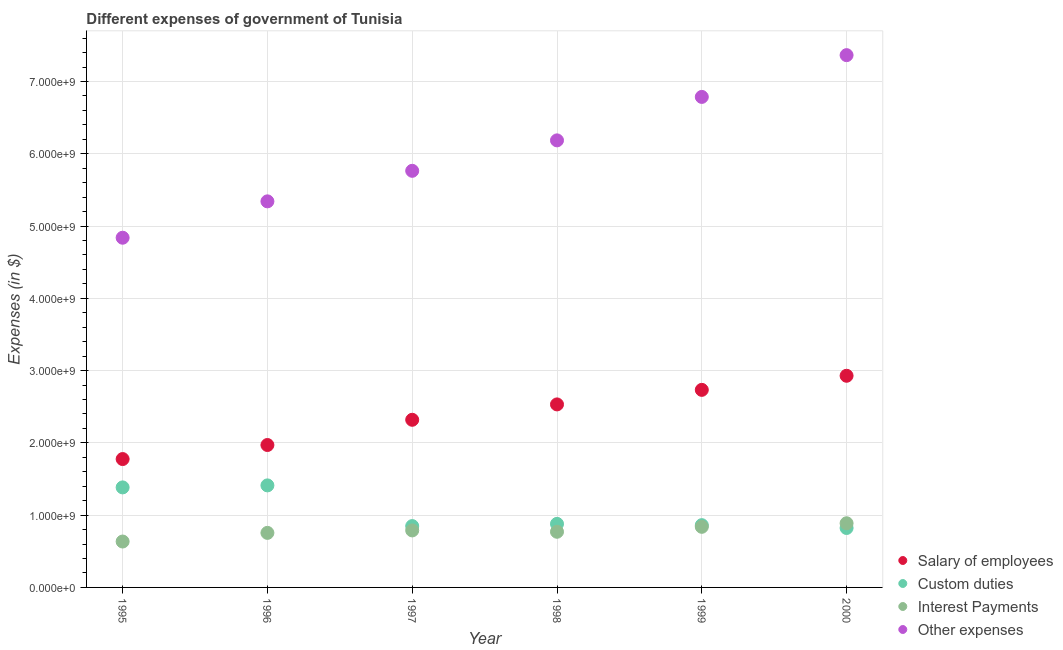How many different coloured dotlines are there?
Your answer should be very brief. 4. Is the number of dotlines equal to the number of legend labels?
Your response must be concise. Yes. What is the amount spent on custom duties in 1997?
Keep it short and to the point. 8.49e+08. Across all years, what is the maximum amount spent on custom duties?
Make the answer very short. 1.41e+09. Across all years, what is the minimum amount spent on custom duties?
Make the answer very short. 8.22e+08. In which year was the amount spent on salary of employees maximum?
Ensure brevity in your answer.  2000. In which year was the amount spent on interest payments minimum?
Provide a succinct answer. 1995. What is the total amount spent on custom duties in the graph?
Give a very brief answer. 6.21e+09. What is the difference between the amount spent on other expenses in 1995 and that in 2000?
Keep it short and to the point. -2.53e+09. What is the difference between the amount spent on interest payments in 1999 and the amount spent on salary of employees in 1996?
Ensure brevity in your answer.  -1.13e+09. What is the average amount spent on interest payments per year?
Ensure brevity in your answer.  7.79e+08. In the year 1995, what is the difference between the amount spent on other expenses and amount spent on interest payments?
Make the answer very short. 4.20e+09. In how many years, is the amount spent on salary of employees greater than 2000000000 $?
Provide a short and direct response. 4. What is the ratio of the amount spent on interest payments in 1995 to that in 1998?
Your response must be concise. 0.82. Is the difference between the amount spent on interest payments in 1996 and 1999 greater than the difference between the amount spent on salary of employees in 1996 and 1999?
Your response must be concise. Yes. What is the difference between the highest and the second highest amount spent on other expenses?
Your response must be concise. 5.78e+08. What is the difference between the highest and the lowest amount spent on other expenses?
Give a very brief answer. 2.53e+09. In how many years, is the amount spent on other expenses greater than the average amount spent on other expenses taken over all years?
Provide a succinct answer. 3. Is the sum of the amount spent on other expenses in 1998 and 2000 greater than the maximum amount spent on salary of employees across all years?
Provide a short and direct response. Yes. Is it the case that in every year, the sum of the amount spent on custom duties and amount spent on interest payments is greater than the sum of amount spent on salary of employees and amount spent on other expenses?
Give a very brief answer. No. Is the amount spent on custom duties strictly greater than the amount spent on other expenses over the years?
Offer a terse response. No. Is the amount spent on salary of employees strictly less than the amount spent on interest payments over the years?
Your answer should be very brief. No. What is the difference between two consecutive major ticks on the Y-axis?
Keep it short and to the point. 1.00e+09. Where does the legend appear in the graph?
Provide a succinct answer. Bottom right. How many legend labels are there?
Give a very brief answer. 4. What is the title of the graph?
Keep it short and to the point. Different expenses of government of Tunisia. What is the label or title of the X-axis?
Ensure brevity in your answer.  Year. What is the label or title of the Y-axis?
Provide a short and direct response. Expenses (in $). What is the Expenses (in $) in Salary of employees in 1995?
Provide a succinct answer. 1.78e+09. What is the Expenses (in $) of Custom duties in 1995?
Your answer should be compact. 1.38e+09. What is the Expenses (in $) of Interest Payments in 1995?
Ensure brevity in your answer.  6.35e+08. What is the Expenses (in $) of Other expenses in 1995?
Ensure brevity in your answer.  4.84e+09. What is the Expenses (in $) in Salary of employees in 1996?
Make the answer very short. 1.97e+09. What is the Expenses (in $) of Custom duties in 1996?
Give a very brief answer. 1.41e+09. What is the Expenses (in $) in Interest Payments in 1996?
Provide a short and direct response. 7.55e+08. What is the Expenses (in $) in Other expenses in 1996?
Provide a succinct answer. 5.34e+09. What is the Expenses (in $) of Salary of employees in 1997?
Provide a succinct answer. 2.32e+09. What is the Expenses (in $) of Custom duties in 1997?
Give a very brief answer. 8.49e+08. What is the Expenses (in $) of Interest Payments in 1997?
Provide a succinct answer. 7.89e+08. What is the Expenses (in $) in Other expenses in 1997?
Your answer should be compact. 5.76e+09. What is the Expenses (in $) of Salary of employees in 1998?
Provide a succinct answer. 2.53e+09. What is the Expenses (in $) of Custom duties in 1998?
Your answer should be compact. 8.79e+08. What is the Expenses (in $) in Interest Payments in 1998?
Your answer should be compact. 7.70e+08. What is the Expenses (in $) in Other expenses in 1998?
Provide a succinct answer. 6.19e+09. What is the Expenses (in $) in Salary of employees in 1999?
Ensure brevity in your answer.  2.73e+09. What is the Expenses (in $) in Custom duties in 1999?
Offer a very short reply. 8.62e+08. What is the Expenses (in $) in Interest Payments in 1999?
Provide a short and direct response. 8.38e+08. What is the Expenses (in $) in Other expenses in 1999?
Keep it short and to the point. 6.79e+09. What is the Expenses (in $) of Salary of employees in 2000?
Your response must be concise. 2.93e+09. What is the Expenses (in $) of Custom duties in 2000?
Offer a very short reply. 8.22e+08. What is the Expenses (in $) in Interest Payments in 2000?
Give a very brief answer. 8.88e+08. What is the Expenses (in $) of Other expenses in 2000?
Keep it short and to the point. 7.36e+09. Across all years, what is the maximum Expenses (in $) in Salary of employees?
Ensure brevity in your answer.  2.93e+09. Across all years, what is the maximum Expenses (in $) of Custom duties?
Your answer should be compact. 1.41e+09. Across all years, what is the maximum Expenses (in $) of Interest Payments?
Your answer should be very brief. 8.88e+08. Across all years, what is the maximum Expenses (in $) in Other expenses?
Give a very brief answer. 7.36e+09. Across all years, what is the minimum Expenses (in $) in Salary of employees?
Keep it short and to the point. 1.78e+09. Across all years, what is the minimum Expenses (in $) in Custom duties?
Ensure brevity in your answer.  8.22e+08. Across all years, what is the minimum Expenses (in $) in Interest Payments?
Your response must be concise. 6.35e+08. Across all years, what is the minimum Expenses (in $) in Other expenses?
Make the answer very short. 4.84e+09. What is the total Expenses (in $) in Salary of employees in the graph?
Your answer should be very brief. 1.43e+1. What is the total Expenses (in $) of Custom duties in the graph?
Give a very brief answer. 6.21e+09. What is the total Expenses (in $) of Interest Payments in the graph?
Provide a short and direct response. 4.67e+09. What is the total Expenses (in $) of Other expenses in the graph?
Give a very brief answer. 3.63e+1. What is the difference between the Expenses (in $) of Salary of employees in 1995 and that in 1996?
Provide a short and direct response. -1.94e+08. What is the difference between the Expenses (in $) in Custom duties in 1995 and that in 1996?
Offer a very short reply. -2.77e+07. What is the difference between the Expenses (in $) of Interest Payments in 1995 and that in 1996?
Ensure brevity in your answer.  -1.20e+08. What is the difference between the Expenses (in $) of Other expenses in 1995 and that in 1996?
Offer a terse response. -5.03e+08. What is the difference between the Expenses (in $) in Salary of employees in 1995 and that in 1997?
Your response must be concise. -5.43e+08. What is the difference between the Expenses (in $) in Custom duties in 1995 and that in 1997?
Keep it short and to the point. 5.35e+08. What is the difference between the Expenses (in $) of Interest Payments in 1995 and that in 1997?
Your answer should be very brief. -1.54e+08. What is the difference between the Expenses (in $) of Other expenses in 1995 and that in 1997?
Offer a terse response. -9.26e+08. What is the difference between the Expenses (in $) of Salary of employees in 1995 and that in 1998?
Your response must be concise. -7.56e+08. What is the difference between the Expenses (in $) in Custom duties in 1995 and that in 1998?
Offer a terse response. 5.05e+08. What is the difference between the Expenses (in $) of Interest Payments in 1995 and that in 1998?
Your response must be concise. -1.35e+08. What is the difference between the Expenses (in $) of Other expenses in 1995 and that in 1998?
Keep it short and to the point. -1.35e+09. What is the difference between the Expenses (in $) of Salary of employees in 1995 and that in 1999?
Provide a succinct answer. -9.57e+08. What is the difference between the Expenses (in $) of Custom duties in 1995 and that in 1999?
Your response must be concise. 5.22e+08. What is the difference between the Expenses (in $) in Interest Payments in 1995 and that in 1999?
Give a very brief answer. -2.03e+08. What is the difference between the Expenses (in $) in Other expenses in 1995 and that in 1999?
Offer a very short reply. -1.95e+09. What is the difference between the Expenses (in $) of Salary of employees in 1995 and that in 2000?
Give a very brief answer. -1.15e+09. What is the difference between the Expenses (in $) in Custom duties in 1995 and that in 2000?
Your response must be concise. 5.62e+08. What is the difference between the Expenses (in $) in Interest Payments in 1995 and that in 2000?
Provide a succinct answer. -2.53e+08. What is the difference between the Expenses (in $) in Other expenses in 1995 and that in 2000?
Your response must be concise. -2.53e+09. What is the difference between the Expenses (in $) of Salary of employees in 1996 and that in 1997?
Offer a very short reply. -3.49e+08. What is the difference between the Expenses (in $) in Custom duties in 1996 and that in 1997?
Provide a short and direct response. 5.63e+08. What is the difference between the Expenses (in $) of Interest Payments in 1996 and that in 1997?
Make the answer very short. -3.40e+07. What is the difference between the Expenses (in $) of Other expenses in 1996 and that in 1997?
Ensure brevity in your answer.  -4.22e+08. What is the difference between the Expenses (in $) in Salary of employees in 1996 and that in 1998?
Your answer should be very brief. -5.62e+08. What is the difference between the Expenses (in $) of Custom duties in 1996 and that in 1998?
Your answer should be very brief. 5.32e+08. What is the difference between the Expenses (in $) in Interest Payments in 1996 and that in 1998?
Provide a succinct answer. -1.53e+07. What is the difference between the Expenses (in $) of Other expenses in 1996 and that in 1998?
Your response must be concise. -8.44e+08. What is the difference between the Expenses (in $) of Salary of employees in 1996 and that in 1999?
Make the answer very short. -7.63e+08. What is the difference between the Expenses (in $) of Custom duties in 1996 and that in 1999?
Your answer should be compact. 5.50e+08. What is the difference between the Expenses (in $) in Interest Payments in 1996 and that in 1999?
Keep it short and to the point. -8.38e+07. What is the difference between the Expenses (in $) of Other expenses in 1996 and that in 1999?
Provide a short and direct response. -1.44e+09. What is the difference between the Expenses (in $) of Salary of employees in 1996 and that in 2000?
Your answer should be very brief. -9.58e+08. What is the difference between the Expenses (in $) in Custom duties in 1996 and that in 2000?
Offer a terse response. 5.89e+08. What is the difference between the Expenses (in $) of Interest Payments in 1996 and that in 2000?
Offer a very short reply. -1.33e+08. What is the difference between the Expenses (in $) in Other expenses in 1996 and that in 2000?
Offer a terse response. -2.02e+09. What is the difference between the Expenses (in $) of Salary of employees in 1997 and that in 1998?
Ensure brevity in your answer.  -2.13e+08. What is the difference between the Expenses (in $) of Custom duties in 1997 and that in 1998?
Your answer should be compact. -3.08e+07. What is the difference between the Expenses (in $) of Interest Payments in 1997 and that in 1998?
Offer a terse response. 1.87e+07. What is the difference between the Expenses (in $) of Other expenses in 1997 and that in 1998?
Keep it short and to the point. -4.21e+08. What is the difference between the Expenses (in $) in Salary of employees in 1997 and that in 1999?
Give a very brief answer. -4.14e+08. What is the difference between the Expenses (in $) of Custom duties in 1997 and that in 1999?
Ensure brevity in your answer.  -1.29e+07. What is the difference between the Expenses (in $) of Interest Payments in 1997 and that in 1999?
Your answer should be very brief. -4.98e+07. What is the difference between the Expenses (in $) in Other expenses in 1997 and that in 1999?
Your response must be concise. -1.02e+09. What is the difference between the Expenses (in $) of Salary of employees in 1997 and that in 2000?
Provide a short and direct response. -6.09e+08. What is the difference between the Expenses (in $) of Custom duties in 1997 and that in 2000?
Provide a succinct answer. 2.62e+07. What is the difference between the Expenses (in $) of Interest Payments in 1997 and that in 2000?
Your answer should be compact. -9.91e+07. What is the difference between the Expenses (in $) of Other expenses in 1997 and that in 2000?
Offer a very short reply. -1.60e+09. What is the difference between the Expenses (in $) of Salary of employees in 1998 and that in 1999?
Give a very brief answer. -2.01e+08. What is the difference between the Expenses (in $) of Custom duties in 1998 and that in 1999?
Your answer should be compact. 1.79e+07. What is the difference between the Expenses (in $) of Interest Payments in 1998 and that in 1999?
Offer a very short reply. -6.85e+07. What is the difference between the Expenses (in $) of Other expenses in 1998 and that in 1999?
Provide a short and direct response. -6.01e+08. What is the difference between the Expenses (in $) in Salary of employees in 1998 and that in 2000?
Provide a succinct answer. -3.96e+08. What is the difference between the Expenses (in $) of Custom duties in 1998 and that in 2000?
Give a very brief answer. 5.70e+07. What is the difference between the Expenses (in $) in Interest Payments in 1998 and that in 2000?
Give a very brief answer. -1.18e+08. What is the difference between the Expenses (in $) of Other expenses in 1998 and that in 2000?
Offer a terse response. -1.18e+09. What is the difference between the Expenses (in $) in Salary of employees in 1999 and that in 2000?
Offer a terse response. -1.95e+08. What is the difference between the Expenses (in $) in Custom duties in 1999 and that in 2000?
Make the answer very short. 3.91e+07. What is the difference between the Expenses (in $) of Interest Payments in 1999 and that in 2000?
Keep it short and to the point. -4.93e+07. What is the difference between the Expenses (in $) in Other expenses in 1999 and that in 2000?
Provide a succinct answer. -5.78e+08. What is the difference between the Expenses (in $) of Salary of employees in 1995 and the Expenses (in $) of Custom duties in 1996?
Provide a succinct answer. 3.64e+08. What is the difference between the Expenses (in $) in Salary of employees in 1995 and the Expenses (in $) in Interest Payments in 1996?
Keep it short and to the point. 1.02e+09. What is the difference between the Expenses (in $) in Salary of employees in 1995 and the Expenses (in $) in Other expenses in 1996?
Offer a terse response. -3.57e+09. What is the difference between the Expenses (in $) in Custom duties in 1995 and the Expenses (in $) in Interest Payments in 1996?
Give a very brief answer. 6.29e+08. What is the difference between the Expenses (in $) of Custom duties in 1995 and the Expenses (in $) of Other expenses in 1996?
Your answer should be compact. -3.96e+09. What is the difference between the Expenses (in $) of Interest Payments in 1995 and the Expenses (in $) of Other expenses in 1996?
Your response must be concise. -4.71e+09. What is the difference between the Expenses (in $) of Salary of employees in 1995 and the Expenses (in $) of Custom duties in 1997?
Your answer should be compact. 9.28e+08. What is the difference between the Expenses (in $) of Salary of employees in 1995 and the Expenses (in $) of Interest Payments in 1997?
Your answer should be very brief. 9.88e+08. What is the difference between the Expenses (in $) of Salary of employees in 1995 and the Expenses (in $) of Other expenses in 1997?
Give a very brief answer. -3.99e+09. What is the difference between the Expenses (in $) of Custom duties in 1995 and the Expenses (in $) of Interest Payments in 1997?
Offer a very short reply. 5.95e+08. What is the difference between the Expenses (in $) in Custom duties in 1995 and the Expenses (in $) in Other expenses in 1997?
Offer a very short reply. -4.38e+09. What is the difference between the Expenses (in $) of Interest Payments in 1995 and the Expenses (in $) of Other expenses in 1997?
Your answer should be compact. -5.13e+09. What is the difference between the Expenses (in $) in Salary of employees in 1995 and the Expenses (in $) in Custom duties in 1998?
Keep it short and to the point. 8.97e+08. What is the difference between the Expenses (in $) in Salary of employees in 1995 and the Expenses (in $) in Interest Payments in 1998?
Your answer should be compact. 1.01e+09. What is the difference between the Expenses (in $) in Salary of employees in 1995 and the Expenses (in $) in Other expenses in 1998?
Offer a very short reply. -4.41e+09. What is the difference between the Expenses (in $) of Custom duties in 1995 and the Expenses (in $) of Interest Payments in 1998?
Ensure brevity in your answer.  6.14e+08. What is the difference between the Expenses (in $) in Custom duties in 1995 and the Expenses (in $) in Other expenses in 1998?
Your response must be concise. -4.80e+09. What is the difference between the Expenses (in $) in Interest Payments in 1995 and the Expenses (in $) in Other expenses in 1998?
Provide a short and direct response. -5.55e+09. What is the difference between the Expenses (in $) of Salary of employees in 1995 and the Expenses (in $) of Custom duties in 1999?
Offer a terse response. 9.15e+08. What is the difference between the Expenses (in $) of Salary of employees in 1995 and the Expenses (in $) of Interest Payments in 1999?
Give a very brief answer. 9.38e+08. What is the difference between the Expenses (in $) of Salary of employees in 1995 and the Expenses (in $) of Other expenses in 1999?
Make the answer very short. -5.01e+09. What is the difference between the Expenses (in $) of Custom duties in 1995 and the Expenses (in $) of Interest Payments in 1999?
Keep it short and to the point. 5.46e+08. What is the difference between the Expenses (in $) of Custom duties in 1995 and the Expenses (in $) of Other expenses in 1999?
Provide a short and direct response. -5.40e+09. What is the difference between the Expenses (in $) of Interest Payments in 1995 and the Expenses (in $) of Other expenses in 1999?
Your response must be concise. -6.15e+09. What is the difference between the Expenses (in $) in Salary of employees in 1995 and the Expenses (in $) in Custom duties in 2000?
Your answer should be very brief. 9.54e+08. What is the difference between the Expenses (in $) of Salary of employees in 1995 and the Expenses (in $) of Interest Payments in 2000?
Give a very brief answer. 8.88e+08. What is the difference between the Expenses (in $) of Salary of employees in 1995 and the Expenses (in $) of Other expenses in 2000?
Your answer should be compact. -5.59e+09. What is the difference between the Expenses (in $) in Custom duties in 1995 and the Expenses (in $) in Interest Payments in 2000?
Make the answer very short. 4.96e+08. What is the difference between the Expenses (in $) of Custom duties in 1995 and the Expenses (in $) of Other expenses in 2000?
Make the answer very short. -5.98e+09. What is the difference between the Expenses (in $) in Interest Payments in 1995 and the Expenses (in $) in Other expenses in 2000?
Your answer should be very brief. -6.73e+09. What is the difference between the Expenses (in $) of Salary of employees in 1996 and the Expenses (in $) of Custom duties in 1997?
Make the answer very short. 1.12e+09. What is the difference between the Expenses (in $) of Salary of employees in 1996 and the Expenses (in $) of Interest Payments in 1997?
Offer a terse response. 1.18e+09. What is the difference between the Expenses (in $) of Salary of employees in 1996 and the Expenses (in $) of Other expenses in 1997?
Make the answer very short. -3.79e+09. What is the difference between the Expenses (in $) of Custom duties in 1996 and the Expenses (in $) of Interest Payments in 1997?
Offer a very short reply. 6.23e+08. What is the difference between the Expenses (in $) in Custom duties in 1996 and the Expenses (in $) in Other expenses in 1997?
Provide a succinct answer. -4.35e+09. What is the difference between the Expenses (in $) in Interest Payments in 1996 and the Expenses (in $) in Other expenses in 1997?
Offer a terse response. -5.01e+09. What is the difference between the Expenses (in $) in Salary of employees in 1996 and the Expenses (in $) in Custom duties in 1998?
Your answer should be very brief. 1.09e+09. What is the difference between the Expenses (in $) in Salary of employees in 1996 and the Expenses (in $) in Interest Payments in 1998?
Your answer should be compact. 1.20e+09. What is the difference between the Expenses (in $) in Salary of employees in 1996 and the Expenses (in $) in Other expenses in 1998?
Your answer should be very brief. -4.21e+09. What is the difference between the Expenses (in $) of Custom duties in 1996 and the Expenses (in $) of Interest Payments in 1998?
Give a very brief answer. 6.42e+08. What is the difference between the Expenses (in $) in Custom duties in 1996 and the Expenses (in $) in Other expenses in 1998?
Provide a succinct answer. -4.77e+09. What is the difference between the Expenses (in $) of Interest Payments in 1996 and the Expenses (in $) of Other expenses in 1998?
Make the answer very short. -5.43e+09. What is the difference between the Expenses (in $) in Salary of employees in 1996 and the Expenses (in $) in Custom duties in 1999?
Provide a succinct answer. 1.11e+09. What is the difference between the Expenses (in $) in Salary of employees in 1996 and the Expenses (in $) in Interest Payments in 1999?
Give a very brief answer. 1.13e+09. What is the difference between the Expenses (in $) of Salary of employees in 1996 and the Expenses (in $) of Other expenses in 1999?
Ensure brevity in your answer.  -4.82e+09. What is the difference between the Expenses (in $) of Custom duties in 1996 and the Expenses (in $) of Interest Payments in 1999?
Your answer should be very brief. 5.73e+08. What is the difference between the Expenses (in $) in Custom duties in 1996 and the Expenses (in $) in Other expenses in 1999?
Provide a short and direct response. -5.38e+09. What is the difference between the Expenses (in $) in Interest Payments in 1996 and the Expenses (in $) in Other expenses in 1999?
Your answer should be very brief. -6.03e+09. What is the difference between the Expenses (in $) of Salary of employees in 1996 and the Expenses (in $) of Custom duties in 2000?
Ensure brevity in your answer.  1.15e+09. What is the difference between the Expenses (in $) of Salary of employees in 1996 and the Expenses (in $) of Interest Payments in 2000?
Provide a succinct answer. 1.08e+09. What is the difference between the Expenses (in $) in Salary of employees in 1996 and the Expenses (in $) in Other expenses in 2000?
Give a very brief answer. -5.39e+09. What is the difference between the Expenses (in $) in Custom duties in 1996 and the Expenses (in $) in Interest Payments in 2000?
Give a very brief answer. 5.24e+08. What is the difference between the Expenses (in $) of Custom duties in 1996 and the Expenses (in $) of Other expenses in 2000?
Offer a terse response. -5.95e+09. What is the difference between the Expenses (in $) of Interest Payments in 1996 and the Expenses (in $) of Other expenses in 2000?
Give a very brief answer. -6.61e+09. What is the difference between the Expenses (in $) in Salary of employees in 1997 and the Expenses (in $) in Custom duties in 1998?
Give a very brief answer. 1.44e+09. What is the difference between the Expenses (in $) in Salary of employees in 1997 and the Expenses (in $) in Interest Payments in 1998?
Ensure brevity in your answer.  1.55e+09. What is the difference between the Expenses (in $) of Salary of employees in 1997 and the Expenses (in $) of Other expenses in 1998?
Ensure brevity in your answer.  -3.87e+09. What is the difference between the Expenses (in $) of Custom duties in 1997 and the Expenses (in $) of Interest Payments in 1998?
Make the answer very short. 7.86e+07. What is the difference between the Expenses (in $) in Custom duties in 1997 and the Expenses (in $) in Other expenses in 1998?
Your answer should be very brief. -5.34e+09. What is the difference between the Expenses (in $) of Interest Payments in 1997 and the Expenses (in $) of Other expenses in 1998?
Offer a very short reply. -5.40e+09. What is the difference between the Expenses (in $) of Salary of employees in 1997 and the Expenses (in $) of Custom duties in 1999?
Offer a very short reply. 1.46e+09. What is the difference between the Expenses (in $) of Salary of employees in 1997 and the Expenses (in $) of Interest Payments in 1999?
Your answer should be very brief. 1.48e+09. What is the difference between the Expenses (in $) of Salary of employees in 1997 and the Expenses (in $) of Other expenses in 1999?
Give a very brief answer. -4.47e+09. What is the difference between the Expenses (in $) of Custom duties in 1997 and the Expenses (in $) of Interest Payments in 1999?
Provide a short and direct response. 1.01e+07. What is the difference between the Expenses (in $) in Custom duties in 1997 and the Expenses (in $) in Other expenses in 1999?
Offer a very short reply. -5.94e+09. What is the difference between the Expenses (in $) in Interest Payments in 1997 and the Expenses (in $) in Other expenses in 1999?
Keep it short and to the point. -6.00e+09. What is the difference between the Expenses (in $) in Salary of employees in 1997 and the Expenses (in $) in Custom duties in 2000?
Ensure brevity in your answer.  1.50e+09. What is the difference between the Expenses (in $) of Salary of employees in 1997 and the Expenses (in $) of Interest Payments in 2000?
Make the answer very short. 1.43e+09. What is the difference between the Expenses (in $) in Salary of employees in 1997 and the Expenses (in $) in Other expenses in 2000?
Keep it short and to the point. -5.05e+09. What is the difference between the Expenses (in $) in Custom duties in 1997 and the Expenses (in $) in Interest Payments in 2000?
Provide a short and direct response. -3.92e+07. What is the difference between the Expenses (in $) of Custom duties in 1997 and the Expenses (in $) of Other expenses in 2000?
Ensure brevity in your answer.  -6.52e+09. What is the difference between the Expenses (in $) in Interest Payments in 1997 and the Expenses (in $) in Other expenses in 2000?
Make the answer very short. -6.58e+09. What is the difference between the Expenses (in $) of Salary of employees in 1998 and the Expenses (in $) of Custom duties in 1999?
Keep it short and to the point. 1.67e+09. What is the difference between the Expenses (in $) in Salary of employees in 1998 and the Expenses (in $) in Interest Payments in 1999?
Provide a succinct answer. 1.69e+09. What is the difference between the Expenses (in $) in Salary of employees in 1998 and the Expenses (in $) in Other expenses in 1999?
Give a very brief answer. -4.25e+09. What is the difference between the Expenses (in $) in Custom duties in 1998 and the Expenses (in $) in Interest Payments in 1999?
Provide a short and direct response. 4.09e+07. What is the difference between the Expenses (in $) in Custom duties in 1998 and the Expenses (in $) in Other expenses in 1999?
Provide a succinct answer. -5.91e+09. What is the difference between the Expenses (in $) in Interest Payments in 1998 and the Expenses (in $) in Other expenses in 1999?
Ensure brevity in your answer.  -6.02e+09. What is the difference between the Expenses (in $) of Salary of employees in 1998 and the Expenses (in $) of Custom duties in 2000?
Your answer should be very brief. 1.71e+09. What is the difference between the Expenses (in $) in Salary of employees in 1998 and the Expenses (in $) in Interest Payments in 2000?
Your response must be concise. 1.64e+09. What is the difference between the Expenses (in $) of Salary of employees in 1998 and the Expenses (in $) of Other expenses in 2000?
Your response must be concise. -4.83e+09. What is the difference between the Expenses (in $) of Custom duties in 1998 and the Expenses (in $) of Interest Payments in 2000?
Your answer should be very brief. -8.40e+06. What is the difference between the Expenses (in $) of Custom duties in 1998 and the Expenses (in $) of Other expenses in 2000?
Your answer should be very brief. -6.49e+09. What is the difference between the Expenses (in $) of Interest Payments in 1998 and the Expenses (in $) of Other expenses in 2000?
Provide a short and direct response. -6.59e+09. What is the difference between the Expenses (in $) in Salary of employees in 1999 and the Expenses (in $) in Custom duties in 2000?
Provide a succinct answer. 1.91e+09. What is the difference between the Expenses (in $) in Salary of employees in 1999 and the Expenses (in $) in Interest Payments in 2000?
Provide a short and direct response. 1.85e+09. What is the difference between the Expenses (in $) of Salary of employees in 1999 and the Expenses (in $) of Other expenses in 2000?
Your answer should be very brief. -4.63e+09. What is the difference between the Expenses (in $) in Custom duties in 1999 and the Expenses (in $) in Interest Payments in 2000?
Your answer should be very brief. -2.63e+07. What is the difference between the Expenses (in $) in Custom duties in 1999 and the Expenses (in $) in Other expenses in 2000?
Your response must be concise. -6.50e+09. What is the difference between the Expenses (in $) of Interest Payments in 1999 and the Expenses (in $) of Other expenses in 2000?
Give a very brief answer. -6.53e+09. What is the average Expenses (in $) in Salary of employees per year?
Give a very brief answer. 2.38e+09. What is the average Expenses (in $) of Custom duties per year?
Offer a terse response. 1.03e+09. What is the average Expenses (in $) in Interest Payments per year?
Offer a terse response. 7.79e+08. What is the average Expenses (in $) in Other expenses per year?
Keep it short and to the point. 6.05e+09. In the year 1995, what is the difference between the Expenses (in $) in Salary of employees and Expenses (in $) in Custom duties?
Your answer should be compact. 3.92e+08. In the year 1995, what is the difference between the Expenses (in $) in Salary of employees and Expenses (in $) in Interest Payments?
Your answer should be compact. 1.14e+09. In the year 1995, what is the difference between the Expenses (in $) of Salary of employees and Expenses (in $) of Other expenses?
Provide a short and direct response. -3.06e+09. In the year 1995, what is the difference between the Expenses (in $) in Custom duties and Expenses (in $) in Interest Payments?
Make the answer very short. 7.49e+08. In the year 1995, what is the difference between the Expenses (in $) in Custom duties and Expenses (in $) in Other expenses?
Offer a terse response. -3.45e+09. In the year 1995, what is the difference between the Expenses (in $) in Interest Payments and Expenses (in $) in Other expenses?
Ensure brevity in your answer.  -4.20e+09. In the year 1996, what is the difference between the Expenses (in $) in Salary of employees and Expenses (in $) in Custom duties?
Ensure brevity in your answer.  5.59e+08. In the year 1996, what is the difference between the Expenses (in $) in Salary of employees and Expenses (in $) in Interest Payments?
Make the answer very short. 1.22e+09. In the year 1996, what is the difference between the Expenses (in $) in Salary of employees and Expenses (in $) in Other expenses?
Provide a short and direct response. -3.37e+09. In the year 1996, what is the difference between the Expenses (in $) of Custom duties and Expenses (in $) of Interest Payments?
Make the answer very short. 6.57e+08. In the year 1996, what is the difference between the Expenses (in $) in Custom duties and Expenses (in $) in Other expenses?
Make the answer very short. -3.93e+09. In the year 1996, what is the difference between the Expenses (in $) in Interest Payments and Expenses (in $) in Other expenses?
Your answer should be very brief. -4.59e+09. In the year 1997, what is the difference between the Expenses (in $) in Salary of employees and Expenses (in $) in Custom duties?
Your answer should be very brief. 1.47e+09. In the year 1997, what is the difference between the Expenses (in $) in Salary of employees and Expenses (in $) in Interest Payments?
Make the answer very short. 1.53e+09. In the year 1997, what is the difference between the Expenses (in $) in Salary of employees and Expenses (in $) in Other expenses?
Offer a terse response. -3.44e+09. In the year 1997, what is the difference between the Expenses (in $) of Custom duties and Expenses (in $) of Interest Payments?
Provide a succinct answer. 5.99e+07. In the year 1997, what is the difference between the Expenses (in $) in Custom duties and Expenses (in $) in Other expenses?
Your response must be concise. -4.92e+09. In the year 1997, what is the difference between the Expenses (in $) of Interest Payments and Expenses (in $) of Other expenses?
Ensure brevity in your answer.  -4.98e+09. In the year 1998, what is the difference between the Expenses (in $) of Salary of employees and Expenses (in $) of Custom duties?
Offer a terse response. 1.65e+09. In the year 1998, what is the difference between the Expenses (in $) of Salary of employees and Expenses (in $) of Interest Payments?
Your answer should be very brief. 1.76e+09. In the year 1998, what is the difference between the Expenses (in $) in Salary of employees and Expenses (in $) in Other expenses?
Your response must be concise. -3.65e+09. In the year 1998, what is the difference between the Expenses (in $) of Custom duties and Expenses (in $) of Interest Payments?
Offer a very short reply. 1.09e+08. In the year 1998, what is the difference between the Expenses (in $) of Custom duties and Expenses (in $) of Other expenses?
Provide a short and direct response. -5.31e+09. In the year 1998, what is the difference between the Expenses (in $) in Interest Payments and Expenses (in $) in Other expenses?
Provide a succinct answer. -5.42e+09. In the year 1999, what is the difference between the Expenses (in $) of Salary of employees and Expenses (in $) of Custom duties?
Give a very brief answer. 1.87e+09. In the year 1999, what is the difference between the Expenses (in $) of Salary of employees and Expenses (in $) of Interest Payments?
Offer a very short reply. 1.90e+09. In the year 1999, what is the difference between the Expenses (in $) in Salary of employees and Expenses (in $) in Other expenses?
Offer a terse response. -4.05e+09. In the year 1999, what is the difference between the Expenses (in $) of Custom duties and Expenses (in $) of Interest Payments?
Provide a short and direct response. 2.30e+07. In the year 1999, what is the difference between the Expenses (in $) of Custom duties and Expenses (in $) of Other expenses?
Offer a terse response. -5.93e+09. In the year 1999, what is the difference between the Expenses (in $) in Interest Payments and Expenses (in $) in Other expenses?
Give a very brief answer. -5.95e+09. In the year 2000, what is the difference between the Expenses (in $) of Salary of employees and Expenses (in $) of Custom duties?
Offer a terse response. 2.11e+09. In the year 2000, what is the difference between the Expenses (in $) of Salary of employees and Expenses (in $) of Interest Payments?
Provide a short and direct response. 2.04e+09. In the year 2000, what is the difference between the Expenses (in $) in Salary of employees and Expenses (in $) in Other expenses?
Your answer should be very brief. -4.44e+09. In the year 2000, what is the difference between the Expenses (in $) in Custom duties and Expenses (in $) in Interest Payments?
Your answer should be very brief. -6.54e+07. In the year 2000, what is the difference between the Expenses (in $) in Custom duties and Expenses (in $) in Other expenses?
Your answer should be compact. -6.54e+09. In the year 2000, what is the difference between the Expenses (in $) in Interest Payments and Expenses (in $) in Other expenses?
Ensure brevity in your answer.  -6.48e+09. What is the ratio of the Expenses (in $) in Salary of employees in 1995 to that in 1996?
Provide a succinct answer. 0.9. What is the ratio of the Expenses (in $) of Custom duties in 1995 to that in 1996?
Provide a short and direct response. 0.98. What is the ratio of the Expenses (in $) of Interest Payments in 1995 to that in 1996?
Your response must be concise. 0.84. What is the ratio of the Expenses (in $) of Other expenses in 1995 to that in 1996?
Keep it short and to the point. 0.91. What is the ratio of the Expenses (in $) in Salary of employees in 1995 to that in 1997?
Provide a succinct answer. 0.77. What is the ratio of the Expenses (in $) in Custom duties in 1995 to that in 1997?
Ensure brevity in your answer.  1.63. What is the ratio of the Expenses (in $) in Interest Payments in 1995 to that in 1997?
Your answer should be compact. 0.81. What is the ratio of the Expenses (in $) in Other expenses in 1995 to that in 1997?
Your answer should be compact. 0.84. What is the ratio of the Expenses (in $) in Salary of employees in 1995 to that in 1998?
Provide a succinct answer. 0.7. What is the ratio of the Expenses (in $) in Custom duties in 1995 to that in 1998?
Make the answer very short. 1.57. What is the ratio of the Expenses (in $) of Interest Payments in 1995 to that in 1998?
Your answer should be compact. 0.82. What is the ratio of the Expenses (in $) in Other expenses in 1995 to that in 1998?
Your answer should be very brief. 0.78. What is the ratio of the Expenses (in $) of Salary of employees in 1995 to that in 1999?
Offer a very short reply. 0.65. What is the ratio of the Expenses (in $) of Custom duties in 1995 to that in 1999?
Give a very brief answer. 1.61. What is the ratio of the Expenses (in $) in Interest Payments in 1995 to that in 1999?
Make the answer very short. 0.76. What is the ratio of the Expenses (in $) in Other expenses in 1995 to that in 1999?
Your response must be concise. 0.71. What is the ratio of the Expenses (in $) of Salary of employees in 1995 to that in 2000?
Keep it short and to the point. 0.61. What is the ratio of the Expenses (in $) in Custom duties in 1995 to that in 2000?
Offer a terse response. 1.68. What is the ratio of the Expenses (in $) of Interest Payments in 1995 to that in 2000?
Your answer should be compact. 0.72. What is the ratio of the Expenses (in $) of Other expenses in 1995 to that in 2000?
Ensure brevity in your answer.  0.66. What is the ratio of the Expenses (in $) in Salary of employees in 1996 to that in 1997?
Offer a terse response. 0.85. What is the ratio of the Expenses (in $) of Custom duties in 1996 to that in 1997?
Offer a terse response. 1.66. What is the ratio of the Expenses (in $) in Interest Payments in 1996 to that in 1997?
Your response must be concise. 0.96. What is the ratio of the Expenses (in $) of Other expenses in 1996 to that in 1997?
Offer a terse response. 0.93. What is the ratio of the Expenses (in $) of Salary of employees in 1996 to that in 1998?
Keep it short and to the point. 0.78. What is the ratio of the Expenses (in $) of Custom duties in 1996 to that in 1998?
Keep it short and to the point. 1.61. What is the ratio of the Expenses (in $) in Interest Payments in 1996 to that in 1998?
Offer a terse response. 0.98. What is the ratio of the Expenses (in $) in Other expenses in 1996 to that in 1998?
Your response must be concise. 0.86. What is the ratio of the Expenses (in $) of Salary of employees in 1996 to that in 1999?
Provide a short and direct response. 0.72. What is the ratio of the Expenses (in $) of Custom duties in 1996 to that in 1999?
Your response must be concise. 1.64. What is the ratio of the Expenses (in $) in Interest Payments in 1996 to that in 1999?
Keep it short and to the point. 0.9. What is the ratio of the Expenses (in $) in Other expenses in 1996 to that in 1999?
Offer a very short reply. 0.79. What is the ratio of the Expenses (in $) of Salary of employees in 1996 to that in 2000?
Your answer should be compact. 0.67. What is the ratio of the Expenses (in $) of Custom duties in 1996 to that in 2000?
Your response must be concise. 1.72. What is the ratio of the Expenses (in $) in Interest Payments in 1996 to that in 2000?
Your answer should be compact. 0.85. What is the ratio of the Expenses (in $) of Other expenses in 1996 to that in 2000?
Provide a succinct answer. 0.73. What is the ratio of the Expenses (in $) in Salary of employees in 1997 to that in 1998?
Offer a terse response. 0.92. What is the ratio of the Expenses (in $) in Custom duties in 1997 to that in 1998?
Your response must be concise. 0.96. What is the ratio of the Expenses (in $) of Interest Payments in 1997 to that in 1998?
Your answer should be compact. 1.02. What is the ratio of the Expenses (in $) of Other expenses in 1997 to that in 1998?
Keep it short and to the point. 0.93. What is the ratio of the Expenses (in $) in Salary of employees in 1997 to that in 1999?
Provide a succinct answer. 0.85. What is the ratio of the Expenses (in $) in Interest Payments in 1997 to that in 1999?
Give a very brief answer. 0.94. What is the ratio of the Expenses (in $) in Other expenses in 1997 to that in 1999?
Offer a terse response. 0.85. What is the ratio of the Expenses (in $) of Salary of employees in 1997 to that in 2000?
Offer a very short reply. 0.79. What is the ratio of the Expenses (in $) of Custom duties in 1997 to that in 2000?
Provide a short and direct response. 1.03. What is the ratio of the Expenses (in $) of Interest Payments in 1997 to that in 2000?
Make the answer very short. 0.89. What is the ratio of the Expenses (in $) in Other expenses in 1997 to that in 2000?
Your response must be concise. 0.78. What is the ratio of the Expenses (in $) in Salary of employees in 1998 to that in 1999?
Your answer should be compact. 0.93. What is the ratio of the Expenses (in $) in Custom duties in 1998 to that in 1999?
Ensure brevity in your answer.  1.02. What is the ratio of the Expenses (in $) of Interest Payments in 1998 to that in 1999?
Offer a terse response. 0.92. What is the ratio of the Expenses (in $) of Other expenses in 1998 to that in 1999?
Ensure brevity in your answer.  0.91. What is the ratio of the Expenses (in $) in Salary of employees in 1998 to that in 2000?
Offer a very short reply. 0.86. What is the ratio of the Expenses (in $) of Custom duties in 1998 to that in 2000?
Make the answer very short. 1.07. What is the ratio of the Expenses (in $) in Interest Payments in 1998 to that in 2000?
Your response must be concise. 0.87. What is the ratio of the Expenses (in $) in Other expenses in 1998 to that in 2000?
Offer a very short reply. 0.84. What is the ratio of the Expenses (in $) of Salary of employees in 1999 to that in 2000?
Provide a short and direct response. 0.93. What is the ratio of the Expenses (in $) of Custom duties in 1999 to that in 2000?
Keep it short and to the point. 1.05. What is the ratio of the Expenses (in $) in Interest Payments in 1999 to that in 2000?
Make the answer very short. 0.94. What is the ratio of the Expenses (in $) of Other expenses in 1999 to that in 2000?
Your response must be concise. 0.92. What is the difference between the highest and the second highest Expenses (in $) in Salary of employees?
Keep it short and to the point. 1.95e+08. What is the difference between the highest and the second highest Expenses (in $) of Custom duties?
Your answer should be compact. 2.77e+07. What is the difference between the highest and the second highest Expenses (in $) of Interest Payments?
Provide a short and direct response. 4.93e+07. What is the difference between the highest and the second highest Expenses (in $) in Other expenses?
Ensure brevity in your answer.  5.78e+08. What is the difference between the highest and the lowest Expenses (in $) in Salary of employees?
Your answer should be compact. 1.15e+09. What is the difference between the highest and the lowest Expenses (in $) in Custom duties?
Your response must be concise. 5.89e+08. What is the difference between the highest and the lowest Expenses (in $) of Interest Payments?
Make the answer very short. 2.53e+08. What is the difference between the highest and the lowest Expenses (in $) of Other expenses?
Give a very brief answer. 2.53e+09. 